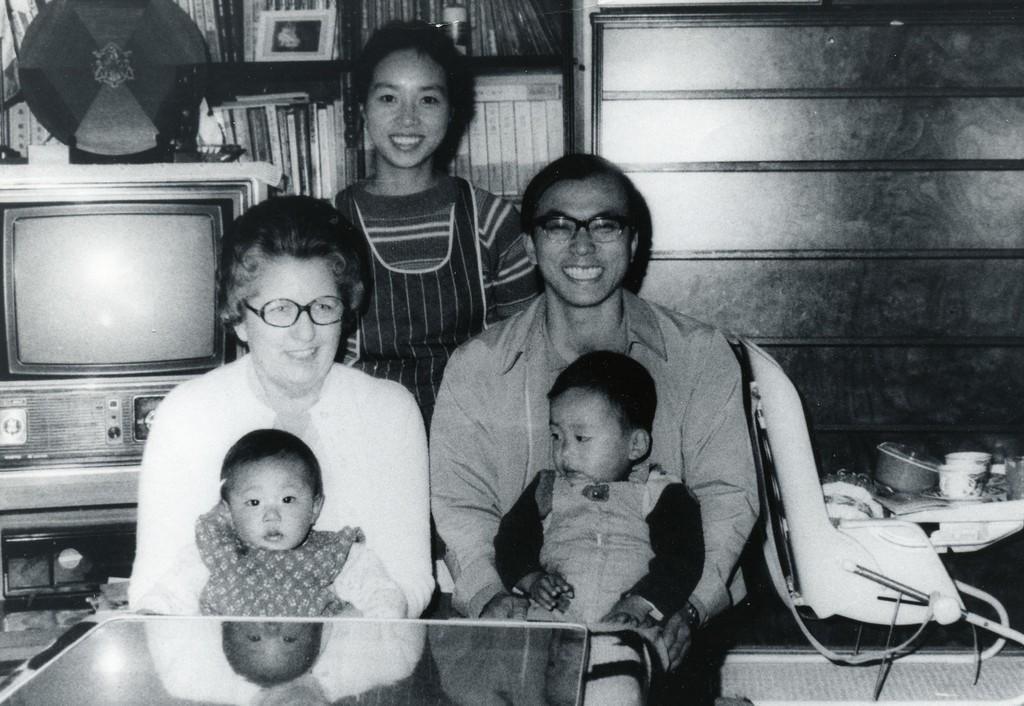Could you give a brief overview of what you see in this image? In this image there are people sitting on the chairs and they are smiling. Behind them there is another person. Beside them there is a chair. There is a table. On top of it there are few objects. In front of them there is a glass table. Behind them there is a TV. There are books on the rack. 